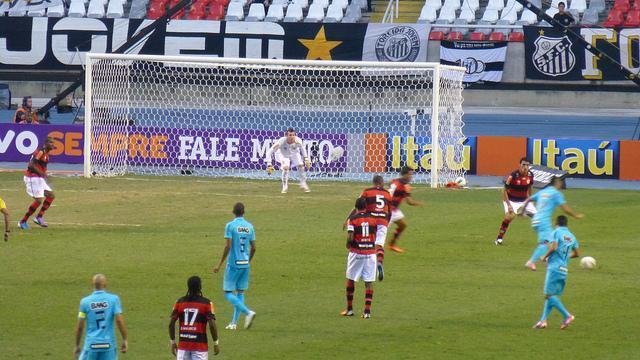How many people are there?
Give a very brief answer. 6. 